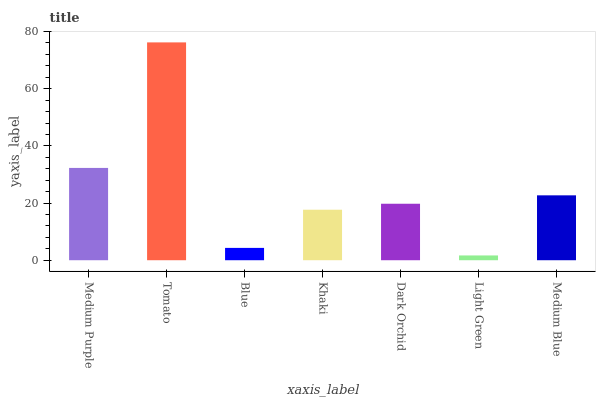Is Blue the minimum?
Answer yes or no. No. Is Blue the maximum?
Answer yes or no. No. Is Tomato greater than Blue?
Answer yes or no. Yes. Is Blue less than Tomato?
Answer yes or no. Yes. Is Blue greater than Tomato?
Answer yes or no. No. Is Tomato less than Blue?
Answer yes or no. No. Is Dark Orchid the high median?
Answer yes or no. Yes. Is Dark Orchid the low median?
Answer yes or no. Yes. Is Khaki the high median?
Answer yes or no. No. Is Light Green the low median?
Answer yes or no. No. 